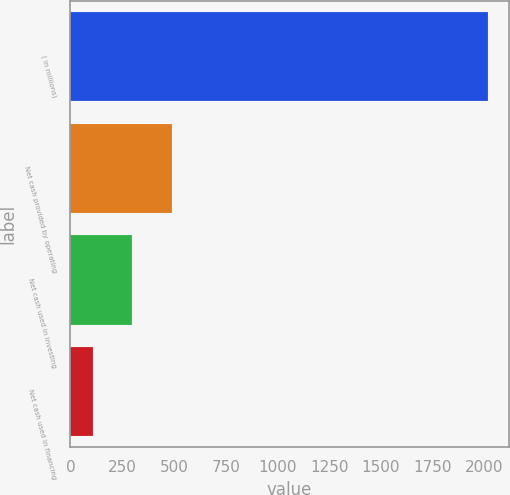Convert chart. <chart><loc_0><loc_0><loc_500><loc_500><bar_chart><fcel>( in millions)<fcel>Net cash provided by operating<fcel>Net cash used in investing<fcel>Net cash used in financing<nl><fcel>2017<fcel>490.6<fcel>299.8<fcel>109<nl></chart> 